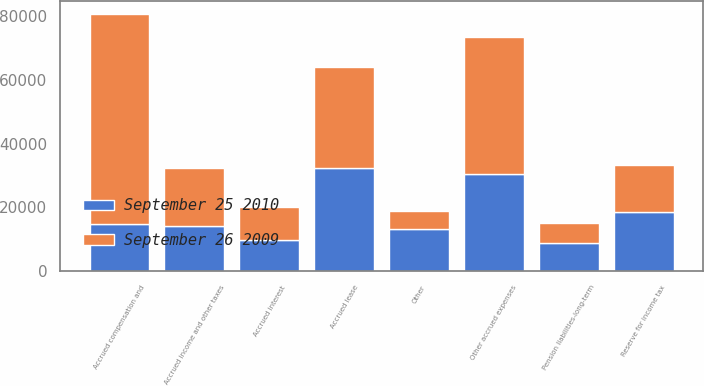Convert chart. <chart><loc_0><loc_0><loc_500><loc_500><stacked_bar_chart><ecel><fcel>Accrued compensation and<fcel>Accrued income and other taxes<fcel>Accrued interest<fcel>Other accrued expenses<fcel>Accrued lease<fcel>Reserve for income tax<fcel>Pension liabilities-long-term<fcel>Other<nl><fcel>September 25 2010<fcel>14728<fcel>14278<fcel>9892<fcel>30550<fcel>32326<fcel>18533<fcel>8756<fcel>13083<nl><fcel>September 26 2009<fcel>66052<fcel>18056<fcel>10184<fcel>42992<fcel>31650<fcel>14728<fcel>6404<fcel>5752<nl></chart> 